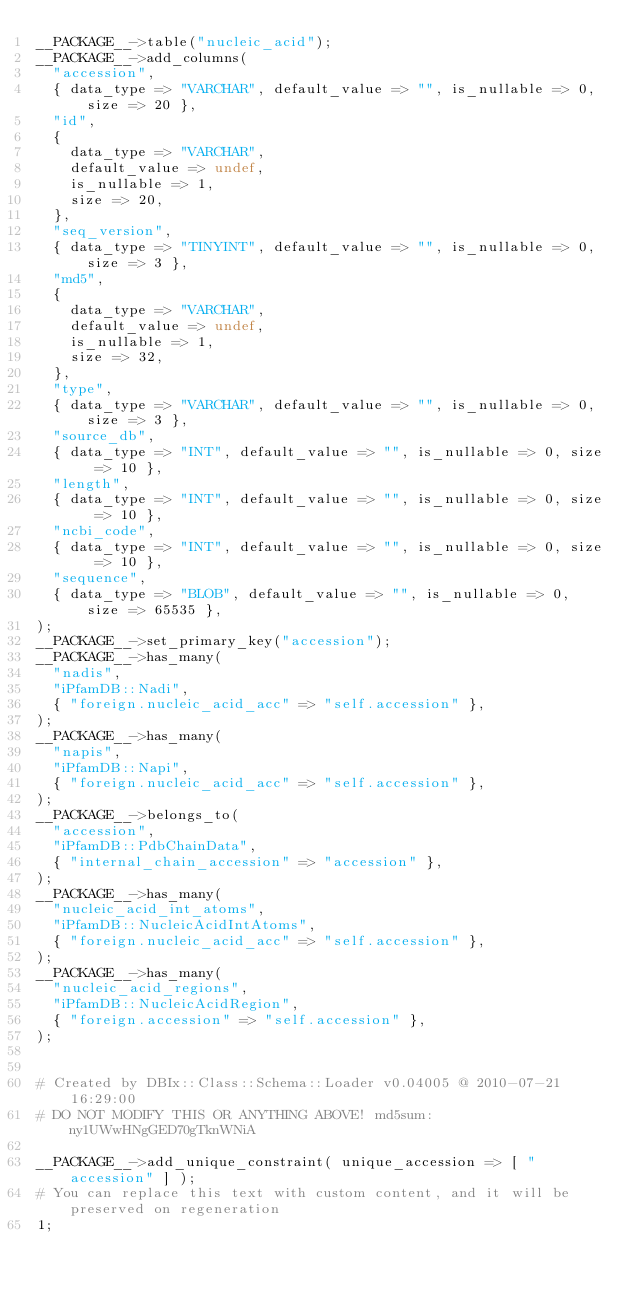Convert code to text. <code><loc_0><loc_0><loc_500><loc_500><_Perl_>__PACKAGE__->table("nucleic_acid");
__PACKAGE__->add_columns(
  "accession",
  { data_type => "VARCHAR", default_value => "", is_nullable => 0, size => 20 },
  "id",
  {
    data_type => "VARCHAR",
    default_value => undef,
    is_nullable => 1,
    size => 20,
  },
  "seq_version",
  { data_type => "TINYINT", default_value => "", is_nullable => 0, size => 3 },
  "md5",
  {
    data_type => "VARCHAR",
    default_value => undef,
    is_nullable => 1,
    size => 32,
  },
  "type",
  { data_type => "VARCHAR", default_value => "", is_nullable => 0, size => 3 },
  "source_db",
  { data_type => "INT", default_value => "", is_nullable => 0, size => 10 },
  "length",
  { data_type => "INT", default_value => "", is_nullable => 0, size => 10 },
  "ncbi_code",
  { data_type => "INT", default_value => "", is_nullable => 0, size => 10 },
  "sequence",
  { data_type => "BLOB", default_value => "", is_nullable => 0, size => 65535 },
);
__PACKAGE__->set_primary_key("accession");
__PACKAGE__->has_many(
  "nadis",
  "iPfamDB::Nadi",
  { "foreign.nucleic_acid_acc" => "self.accession" },
);
__PACKAGE__->has_many(
  "napis",
  "iPfamDB::Napi",
  { "foreign.nucleic_acid_acc" => "self.accession" },
);
__PACKAGE__->belongs_to(
  "accession",
  "iPfamDB::PdbChainData",
  { "internal_chain_accession" => "accession" },
);
__PACKAGE__->has_many(
  "nucleic_acid_int_atoms",
  "iPfamDB::NucleicAcidIntAtoms",
  { "foreign.nucleic_acid_acc" => "self.accession" },
);
__PACKAGE__->has_many(
  "nucleic_acid_regions",
  "iPfamDB::NucleicAcidRegion",
  { "foreign.accession" => "self.accession" },
);


# Created by DBIx::Class::Schema::Loader v0.04005 @ 2010-07-21 16:29:00
# DO NOT MODIFY THIS OR ANYTHING ABOVE! md5sum:ny1UWwHNgGED70gTknWNiA

__PACKAGE__->add_unique_constraint( unique_accession => [ "accession" ] );
# You can replace this text with custom content, and it will be preserved on regeneration
1;
</code> 